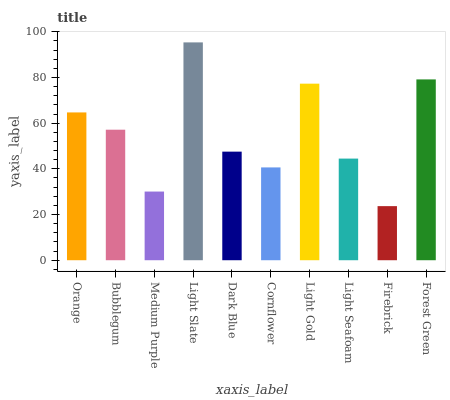Is Bubblegum the minimum?
Answer yes or no. No. Is Bubblegum the maximum?
Answer yes or no. No. Is Orange greater than Bubblegum?
Answer yes or no. Yes. Is Bubblegum less than Orange?
Answer yes or no. Yes. Is Bubblegum greater than Orange?
Answer yes or no. No. Is Orange less than Bubblegum?
Answer yes or no. No. Is Bubblegum the high median?
Answer yes or no. Yes. Is Dark Blue the low median?
Answer yes or no. Yes. Is Forest Green the high median?
Answer yes or no. No. Is Orange the low median?
Answer yes or no. No. 